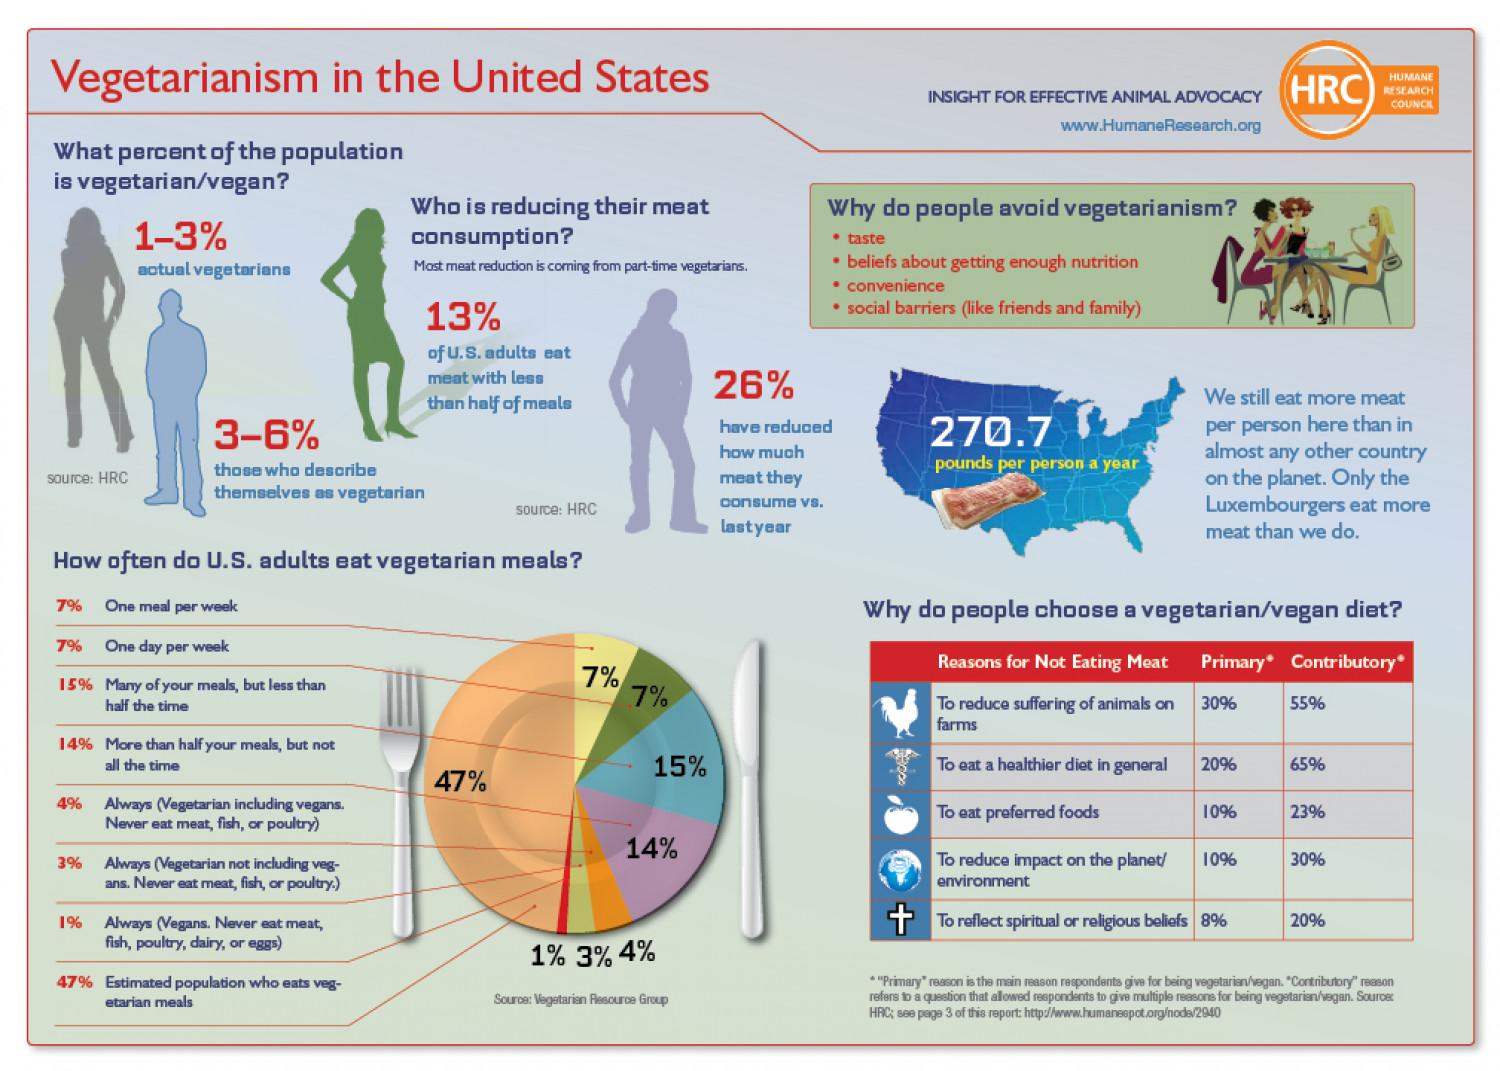Give some essential details in this illustration. According to a recent survey, 26% of Americans have reduced their meat consumption from the previous year. According to a recent survey, only 3 to 6% of Americans consider themselves to be vegetarian. According to a survey, approximately 87% of Americans do not eat meat for less than half of their meals. Four reasons are listed to demonstrate why many Americans avoid vegetarian food. According to recent studies, only 1-3% of Americans are actual vegetarians, meaning they do not consume any meat or animal products. 